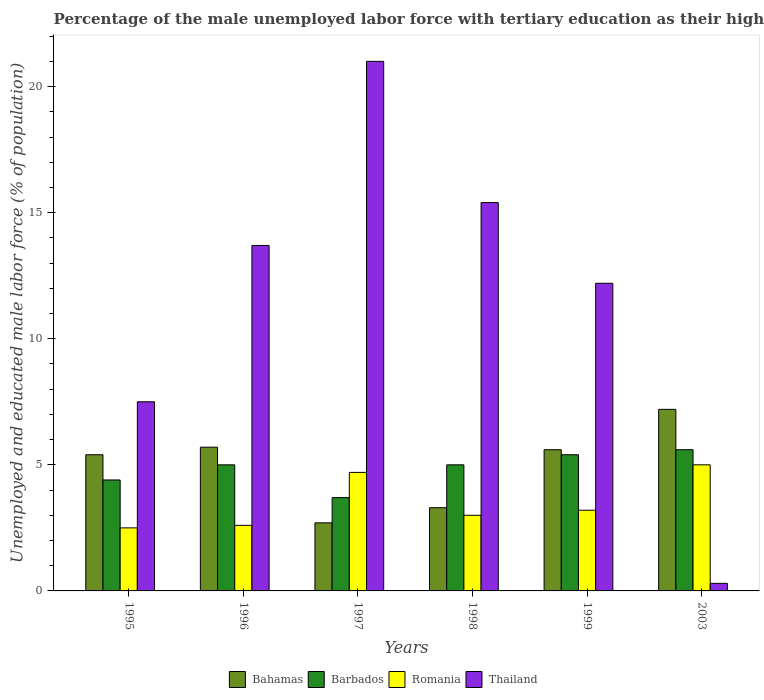How many bars are there on the 4th tick from the left?
Your answer should be very brief. 4. How many bars are there on the 4th tick from the right?
Offer a terse response. 4. In how many cases, is the number of bars for a given year not equal to the number of legend labels?
Offer a very short reply. 0. Across all years, what is the minimum percentage of the unemployed male labor force with tertiary education in Barbados?
Your answer should be very brief. 3.7. In which year was the percentage of the unemployed male labor force with tertiary education in Romania maximum?
Keep it short and to the point. 2003. What is the total percentage of the unemployed male labor force with tertiary education in Thailand in the graph?
Keep it short and to the point. 70.1. What is the difference between the percentage of the unemployed male labor force with tertiary education in Bahamas in 1999 and that in 2003?
Offer a very short reply. -1.6. What is the difference between the percentage of the unemployed male labor force with tertiary education in Barbados in 2003 and the percentage of the unemployed male labor force with tertiary education in Thailand in 1996?
Make the answer very short. -8.1. What is the average percentage of the unemployed male labor force with tertiary education in Thailand per year?
Your response must be concise. 11.68. In the year 1998, what is the difference between the percentage of the unemployed male labor force with tertiary education in Bahamas and percentage of the unemployed male labor force with tertiary education in Romania?
Ensure brevity in your answer.  0.3. In how many years, is the percentage of the unemployed male labor force with tertiary education in Romania greater than 1 %?
Offer a terse response. 6. What is the ratio of the percentage of the unemployed male labor force with tertiary education in Thailand in 1995 to that in 2003?
Your answer should be compact. 25. Is the percentage of the unemployed male labor force with tertiary education in Barbados in 1995 less than that in 1997?
Make the answer very short. No. Is the difference between the percentage of the unemployed male labor force with tertiary education in Bahamas in 1996 and 1998 greater than the difference between the percentage of the unemployed male labor force with tertiary education in Romania in 1996 and 1998?
Provide a short and direct response. Yes. What is the difference between the highest and the second highest percentage of the unemployed male labor force with tertiary education in Thailand?
Offer a terse response. 5.6. What is the difference between the highest and the lowest percentage of the unemployed male labor force with tertiary education in Romania?
Give a very brief answer. 2.5. What does the 3rd bar from the left in 1997 represents?
Give a very brief answer. Romania. What does the 2nd bar from the right in 2003 represents?
Offer a terse response. Romania. Is it the case that in every year, the sum of the percentage of the unemployed male labor force with tertiary education in Romania and percentage of the unemployed male labor force with tertiary education in Bahamas is greater than the percentage of the unemployed male labor force with tertiary education in Thailand?
Give a very brief answer. No. How many bars are there?
Make the answer very short. 24. Are all the bars in the graph horizontal?
Your answer should be compact. No. How many legend labels are there?
Offer a very short reply. 4. What is the title of the graph?
Your answer should be compact. Percentage of the male unemployed labor force with tertiary education as their highest grade. Does "Low income" appear as one of the legend labels in the graph?
Provide a succinct answer. No. What is the label or title of the Y-axis?
Keep it short and to the point. Unemployed and educated male labor force (% of population). What is the Unemployed and educated male labor force (% of population) in Bahamas in 1995?
Give a very brief answer. 5.4. What is the Unemployed and educated male labor force (% of population) in Barbados in 1995?
Keep it short and to the point. 4.4. What is the Unemployed and educated male labor force (% of population) of Romania in 1995?
Provide a short and direct response. 2.5. What is the Unemployed and educated male labor force (% of population) of Thailand in 1995?
Give a very brief answer. 7.5. What is the Unemployed and educated male labor force (% of population) in Bahamas in 1996?
Make the answer very short. 5.7. What is the Unemployed and educated male labor force (% of population) of Barbados in 1996?
Make the answer very short. 5. What is the Unemployed and educated male labor force (% of population) of Romania in 1996?
Offer a very short reply. 2.6. What is the Unemployed and educated male labor force (% of population) of Thailand in 1996?
Your response must be concise. 13.7. What is the Unemployed and educated male labor force (% of population) in Bahamas in 1997?
Keep it short and to the point. 2.7. What is the Unemployed and educated male labor force (% of population) in Barbados in 1997?
Ensure brevity in your answer.  3.7. What is the Unemployed and educated male labor force (% of population) in Romania in 1997?
Keep it short and to the point. 4.7. What is the Unemployed and educated male labor force (% of population) of Thailand in 1997?
Provide a short and direct response. 21. What is the Unemployed and educated male labor force (% of population) in Bahamas in 1998?
Your response must be concise. 3.3. What is the Unemployed and educated male labor force (% of population) in Thailand in 1998?
Offer a terse response. 15.4. What is the Unemployed and educated male labor force (% of population) of Bahamas in 1999?
Give a very brief answer. 5.6. What is the Unemployed and educated male labor force (% of population) of Barbados in 1999?
Your answer should be compact. 5.4. What is the Unemployed and educated male labor force (% of population) in Romania in 1999?
Give a very brief answer. 3.2. What is the Unemployed and educated male labor force (% of population) of Thailand in 1999?
Give a very brief answer. 12.2. What is the Unemployed and educated male labor force (% of population) in Bahamas in 2003?
Keep it short and to the point. 7.2. What is the Unemployed and educated male labor force (% of population) in Barbados in 2003?
Your answer should be very brief. 5.6. What is the Unemployed and educated male labor force (% of population) of Romania in 2003?
Your response must be concise. 5. What is the Unemployed and educated male labor force (% of population) of Thailand in 2003?
Keep it short and to the point. 0.3. Across all years, what is the maximum Unemployed and educated male labor force (% of population) of Bahamas?
Offer a very short reply. 7.2. Across all years, what is the maximum Unemployed and educated male labor force (% of population) of Barbados?
Your response must be concise. 5.6. Across all years, what is the maximum Unemployed and educated male labor force (% of population) in Thailand?
Ensure brevity in your answer.  21. Across all years, what is the minimum Unemployed and educated male labor force (% of population) in Bahamas?
Keep it short and to the point. 2.7. Across all years, what is the minimum Unemployed and educated male labor force (% of population) of Barbados?
Give a very brief answer. 3.7. Across all years, what is the minimum Unemployed and educated male labor force (% of population) in Thailand?
Your answer should be compact. 0.3. What is the total Unemployed and educated male labor force (% of population) of Bahamas in the graph?
Your response must be concise. 29.9. What is the total Unemployed and educated male labor force (% of population) in Barbados in the graph?
Give a very brief answer. 29.1. What is the total Unemployed and educated male labor force (% of population) in Romania in the graph?
Provide a succinct answer. 21. What is the total Unemployed and educated male labor force (% of population) of Thailand in the graph?
Your answer should be compact. 70.1. What is the difference between the Unemployed and educated male labor force (% of population) of Romania in 1995 and that in 1996?
Provide a succinct answer. -0.1. What is the difference between the Unemployed and educated male labor force (% of population) in Bahamas in 1995 and that in 1997?
Your answer should be very brief. 2.7. What is the difference between the Unemployed and educated male labor force (% of population) in Romania in 1995 and that in 1997?
Keep it short and to the point. -2.2. What is the difference between the Unemployed and educated male labor force (% of population) of Thailand in 1995 and that in 1997?
Provide a short and direct response. -13.5. What is the difference between the Unemployed and educated male labor force (% of population) in Bahamas in 1995 and that in 1998?
Your response must be concise. 2.1. What is the difference between the Unemployed and educated male labor force (% of population) of Romania in 1995 and that in 1998?
Make the answer very short. -0.5. What is the difference between the Unemployed and educated male labor force (% of population) of Thailand in 1995 and that in 1998?
Offer a very short reply. -7.9. What is the difference between the Unemployed and educated male labor force (% of population) of Bahamas in 1995 and that in 1999?
Your answer should be very brief. -0.2. What is the difference between the Unemployed and educated male labor force (% of population) of Barbados in 1995 and that in 1999?
Give a very brief answer. -1. What is the difference between the Unemployed and educated male labor force (% of population) of Romania in 1995 and that in 1999?
Your answer should be very brief. -0.7. What is the difference between the Unemployed and educated male labor force (% of population) in Thailand in 1995 and that in 1999?
Keep it short and to the point. -4.7. What is the difference between the Unemployed and educated male labor force (% of population) in Barbados in 1995 and that in 2003?
Provide a succinct answer. -1.2. What is the difference between the Unemployed and educated male labor force (% of population) in Thailand in 1995 and that in 2003?
Offer a very short reply. 7.2. What is the difference between the Unemployed and educated male labor force (% of population) of Bahamas in 1996 and that in 1997?
Provide a short and direct response. 3. What is the difference between the Unemployed and educated male labor force (% of population) in Romania in 1996 and that in 1997?
Offer a very short reply. -2.1. What is the difference between the Unemployed and educated male labor force (% of population) in Thailand in 1996 and that in 1997?
Offer a terse response. -7.3. What is the difference between the Unemployed and educated male labor force (% of population) in Barbados in 1996 and that in 1998?
Your response must be concise. 0. What is the difference between the Unemployed and educated male labor force (% of population) in Romania in 1996 and that in 1998?
Give a very brief answer. -0.4. What is the difference between the Unemployed and educated male labor force (% of population) of Bahamas in 1996 and that in 1999?
Give a very brief answer. 0.1. What is the difference between the Unemployed and educated male labor force (% of population) of Barbados in 1996 and that in 1999?
Your response must be concise. -0.4. What is the difference between the Unemployed and educated male labor force (% of population) in Thailand in 1996 and that in 1999?
Your answer should be compact. 1.5. What is the difference between the Unemployed and educated male labor force (% of population) of Bahamas in 1996 and that in 2003?
Ensure brevity in your answer.  -1.5. What is the difference between the Unemployed and educated male labor force (% of population) in Barbados in 1996 and that in 2003?
Provide a succinct answer. -0.6. What is the difference between the Unemployed and educated male labor force (% of population) of Thailand in 1996 and that in 2003?
Offer a terse response. 13.4. What is the difference between the Unemployed and educated male labor force (% of population) in Bahamas in 1997 and that in 1998?
Your response must be concise. -0.6. What is the difference between the Unemployed and educated male labor force (% of population) in Barbados in 1997 and that in 1998?
Your response must be concise. -1.3. What is the difference between the Unemployed and educated male labor force (% of population) of Thailand in 1997 and that in 1998?
Ensure brevity in your answer.  5.6. What is the difference between the Unemployed and educated male labor force (% of population) of Bahamas in 1997 and that in 1999?
Provide a short and direct response. -2.9. What is the difference between the Unemployed and educated male labor force (% of population) of Barbados in 1997 and that in 1999?
Ensure brevity in your answer.  -1.7. What is the difference between the Unemployed and educated male labor force (% of population) in Thailand in 1997 and that in 1999?
Your response must be concise. 8.8. What is the difference between the Unemployed and educated male labor force (% of population) of Bahamas in 1997 and that in 2003?
Your answer should be very brief. -4.5. What is the difference between the Unemployed and educated male labor force (% of population) in Barbados in 1997 and that in 2003?
Provide a succinct answer. -1.9. What is the difference between the Unemployed and educated male labor force (% of population) of Thailand in 1997 and that in 2003?
Your response must be concise. 20.7. What is the difference between the Unemployed and educated male labor force (% of population) of Bahamas in 1998 and that in 1999?
Keep it short and to the point. -2.3. What is the difference between the Unemployed and educated male labor force (% of population) in Barbados in 1998 and that in 1999?
Make the answer very short. -0.4. What is the difference between the Unemployed and educated male labor force (% of population) of Thailand in 1998 and that in 1999?
Your response must be concise. 3.2. What is the difference between the Unemployed and educated male labor force (% of population) of Bahamas in 1998 and that in 2003?
Make the answer very short. -3.9. What is the difference between the Unemployed and educated male labor force (% of population) of Barbados in 1998 and that in 2003?
Provide a short and direct response. -0.6. What is the difference between the Unemployed and educated male labor force (% of population) in Romania in 1998 and that in 2003?
Provide a succinct answer. -2. What is the difference between the Unemployed and educated male labor force (% of population) of Thailand in 1998 and that in 2003?
Ensure brevity in your answer.  15.1. What is the difference between the Unemployed and educated male labor force (% of population) in Bahamas in 1999 and that in 2003?
Ensure brevity in your answer.  -1.6. What is the difference between the Unemployed and educated male labor force (% of population) in Bahamas in 1995 and the Unemployed and educated male labor force (% of population) in Barbados in 1996?
Offer a very short reply. 0.4. What is the difference between the Unemployed and educated male labor force (% of population) in Bahamas in 1995 and the Unemployed and educated male labor force (% of population) in Romania in 1996?
Keep it short and to the point. 2.8. What is the difference between the Unemployed and educated male labor force (% of population) in Barbados in 1995 and the Unemployed and educated male labor force (% of population) in Thailand in 1996?
Provide a succinct answer. -9.3. What is the difference between the Unemployed and educated male labor force (% of population) in Romania in 1995 and the Unemployed and educated male labor force (% of population) in Thailand in 1996?
Your answer should be very brief. -11.2. What is the difference between the Unemployed and educated male labor force (% of population) in Bahamas in 1995 and the Unemployed and educated male labor force (% of population) in Romania in 1997?
Your response must be concise. 0.7. What is the difference between the Unemployed and educated male labor force (% of population) of Bahamas in 1995 and the Unemployed and educated male labor force (% of population) of Thailand in 1997?
Keep it short and to the point. -15.6. What is the difference between the Unemployed and educated male labor force (% of population) of Barbados in 1995 and the Unemployed and educated male labor force (% of population) of Romania in 1997?
Offer a very short reply. -0.3. What is the difference between the Unemployed and educated male labor force (% of population) in Barbados in 1995 and the Unemployed and educated male labor force (% of population) in Thailand in 1997?
Your answer should be compact. -16.6. What is the difference between the Unemployed and educated male labor force (% of population) of Romania in 1995 and the Unemployed and educated male labor force (% of population) of Thailand in 1997?
Provide a succinct answer. -18.5. What is the difference between the Unemployed and educated male labor force (% of population) of Bahamas in 1995 and the Unemployed and educated male labor force (% of population) of Romania in 1998?
Offer a very short reply. 2.4. What is the difference between the Unemployed and educated male labor force (% of population) of Bahamas in 1995 and the Unemployed and educated male labor force (% of population) of Thailand in 1998?
Provide a succinct answer. -10. What is the difference between the Unemployed and educated male labor force (% of population) of Barbados in 1995 and the Unemployed and educated male labor force (% of population) of Romania in 1998?
Your answer should be compact. 1.4. What is the difference between the Unemployed and educated male labor force (% of population) in Barbados in 1995 and the Unemployed and educated male labor force (% of population) in Thailand in 1998?
Keep it short and to the point. -11. What is the difference between the Unemployed and educated male labor force (% of population) in Bahamas in 1995 and the Unemployed and educated male labor force (% of population) in Barbados in 1999?
Provide a short and direct response. 0. What is the difference between the Unemployed and educated male labor force (% of population) of Bahamas in 1995 and the Unemployed and educated male labor force (% of population) of Romania in 1999?
Your response must be concise. 2.2. What is the difference between the Unemployed and educated male labor force (% of population) of Bahamas in 1995 and the Unemployed and educated male labor force (% of population) of Thailand in 1999?
Provide a succinct answer. -6.8. What is the difference between the Unemployed and educated male labor force (% of population) of Barbados in 1995 and the Unemployed and educated male labor force (% of population) of Romania in 1999?
Your response must be concise. 1.2. What is the difference between the Unemployed and educated male labor force (% of population) of Barbados in 1995 and the Unemployed and educated male labor force (% of population) of Thailand in 1999?
Your answer should be compact. -7.8. What is the difference between the Unemployed and educated male labor force (% of population) of Barbados in 1995 and the Unemployed and educated male labor force (% of population) of Thailand in 2003?
Give a very brief answer. 4.1. What is the difference between the Unemployed and educated male labor force (% of population) of Bahamas in 1996 and the Unemployed and educated male labor force (% of population) of Barbados in 1997?
Give a very brief answer. 2. What is the difference between the Unemployed and educated male labor force (% of population) of Bahamas in 1996 and the Unemployed and educated male labor force (% of population) of Thailand in 1997?
Your response must be concise. -15.3. What is the difference between the Unemployed and educated male labor force (% of population) of Barbados in 1996 and the Unemployed and educated male labor force (% of population) of Thailand in 1997?
Make the answer very short. -16. What is the difference between the Unemployed and educated male labor force (% of population) in Romania in 1996 and the Unemployed and educated male labor force (% of population) in Thailand in 1997?
Provide a short and direct response. -18.4. What is the difference between the Unemployed and educated male labor force (% of population) of Bahamas in 1996 and the Unemployed and educated male labor force (% of population) of Barbados in 1998?
Provide a succinct answer. 0.7. What is the difference between the Unemployed and educated male labor force (% of population) in Bahamas in 1996 and the Unemployed and educated male labor force (% of population) in Thailand in 1998?
Make the answer very short. -9.7. What is the difference between the Unemployed and educated male labor force (% of population) of Barbados in 1996 and the Unemployed and educated male labor force (% of population) of Thailand in 1998?
Make the answer very short. -10.4. What is the difference between the Unemployed and educated male labor force (% of population) in Romania in 1996 and the Unemployed and educated male labor force (% of population) in Thailand in 1998?
Ensure brevity in your answer.  -12.8. What is the difference between the Unemployed and educated male labor force (% of population) of Bahamas in 1996 and the Unemployed and educated male labor force (% of population) of Thailand in 1999?
Your response must be concise. -6.5. What is the difference between the Unemployed and educated male labor force (% of population) of Barbados in 1996 and the Unemployed and educated male labor force (% of population) of Romania in 1999?
Give a very brief answer. 1.8. What is the difference between the Unemployed and educated male labor force (% of population) of Barbados in 1996 and the Unemployed and educated male labor force (% of population) of Thailand in 1999?
Your answer should be compact. -7.2. What is the difference between the Unemployed and educated male labor force (% of population) of Bahamas in 1996 and the Unemployed and educated male labor force (% of population) of Barbados in 2003?
Your response must be concise. 0.1. What is the difference between the Unemployed and educated male labor force (% of population) of Bahamas in 1996 and the Unemployed and educated male labor force (% of population) of Thailand in 2003?
Offer a very short reply. 5.4. What is the difference between the Unemployed and educated male labor force (% of population) in Barbados in 1996 and the Unemployed and educated male labor force (% of population) in Romania in 2003?
Provide a succinct answer. 0. What is the difference between the Unemployed and educated male labor force (% of population) of Bahamas in 1997 and the Unemployed and educated male labor force (% of population) of Romania in 1998?
Offer a very short reply. -0.3. What is the difference between the Unemployed and educated male labor force (% of population) of Barbados in 1997 and the Unemployed and educated male labor force (% of population) of Romania in 1998?
Your answer should be very brief. 0.7. What is the difference between the Unemployed and educated male labor force (% of population) in Romania in 1997 and the Unemployed and educated male labor force (% of population) in Thailand in 1998?
Offer a terse response. -10.7. What is the difference between the Unemployed and educated male labor force (% of population) of Bahamas in 1997 and the Unemployed and educated male labor force (% of population) of Barbados in 1999?
Provide a succinct answer. -2.7. What is the difference between the Unemployed and educated male labor force (% of population) of Bahamas in 1997 and the Unemployed and educated male labor force (% of population) of Thailand in 1999?
Give a very brief answer. -9.5. What is the difference between the Unemployed and educated male labor force (% of population) in Barbados in 1997 and the Unemployed and educated male labor force (% of population) in Romania in 1999?
Offer a terse response. 0.5. What is the difference between the Unemployed and educated male labor force (% of population) in Bahamas in 1997 and the Unemployed and educated male labor force (% of population) in Barbados in 2003?
Your response must be concise. -2.9. What is the difference between the Unemployed and educated male labor force (% of population) of Bahamas in 1997 and the Unemployed and educated male labor force (% of population) of Romania in 2003?
Make the answer very short. -2.3. What is the difference between the Unemployed and educated male labor force (% of population) in Bahamas in 1997 and the Unemployed and educated male labor force (% of population) in Thailand in 2003?
Make the answer very short. 2.4. What is the difference between the Unemployed and educated male labor force (% of population) in Barbados in 1997 and the Unemployed and educated male labor force (% of population) in Romania in 2003?
Your response must be concise. -1.3. What is the difference between the Unemployed and educated male labor force (% of population) of Romania in 1997 and the Unemployed and educated male labor force (% of population) of Thailand in 2003?
Ensure brevity in your answer.  4.4. What is the difference between the Unemployed and educated male labor force (% of population) in Bahamas in 1998 and the Unemployed and educated male labor force (% of population) in Romania in 1999?
Give a very brief answer. 0.1. What is the difference between the Unemployed and educated male labor force (% of population) of Bahamas in 1998 and the Unemployed and educated male labor force (% of population) of Thailand in 1999?
Ensure brevity in your answer.  -8.9. What is the difference between the Unemployed and educated male labor force (% of population) of Romania in 1998 and the Unemployed and educated male labor force (% of population) of Thailand in 1999?
Provide a short and direct response. -9.2. What is the difference between the Unemployed and educated male labor force (% of population) in Bahamas in 1998 and the Unemployed and educated male labor force (% of population) in Barbados in 2003?
Offer a terse response. -2.3. What is the difference between the Unemployed and educated male labor force (% of population) of Bahamas in 1998 and the Unemployed and educated male labor force (% of population) of Romania in 2003?
Offer a terse response. -1.7. What is the difference between the Unemployed and educated male labor force (% of population) of Barbados in 1998 and the Unemployed and educated male labor force (% of population) of Romania in 2003?
Offer a terse response. 0. What is the difference between the Unemployed and educated male labor force (% of population) in Barbados in 1998 and the Unemployed and educated male labor force (% of population) in Thailand in 2003?
Offer a terse response. 4.7. What is the difference between the Unemployed and educated male labor force (% of population) in Bahamas in 1999 and the Unemployed and educated male labor force (% of population) in Barbados in 2003?
Your answer should be very brief. 0. What is the difference between the Unemployed and educated male labor force (% of population) of Bahamas in 1999 and the Unemployed and educated male labor force (% of population) of Thailand in 2003?
Ensure brevity in your answer.  5.3. What is the difference between the Unemployed and educated male labor force (% of population) of Barbados in 1999 and the Unemployed and educated male labor force (% of population) of Thailand in 2003?
Give a very brief answer. 5.1. What is the average Unemployed and educated male labor force (% of population) of Bahamas per year?
Keep it short and to the point. 4.98. What is the average Unemployed and educated male labor force (% of population) of Barbados per year?
Your answer should be very brief. 4.85. What is the average Unemployed and educated male labor force (% of population) in Romania per year?
Your answer should be compact. 3.5. What is the average Unemployed and educated male labor force (% of population) in Thailand per year?
Your answer should be very brief. 11.68. In the year 1995, what is the difference between the Unemployed and educated male labor force (% of population) in Bahamas and Unemployed and educated male labor force (% of population) in Romania?
Provide a short and direct response. 2.9. In the year 1996, what is the difference between the Unemployed and educated male labor force (% of population) in Bahamas and Unemployed and educated male labor force (% of population) in Barbados?
Provide a short and direct response. 0.7. In the year 1996, what is the difference between the Unemployed and educated male labor force (% of population) of Bahamas and Unemployed and educated male labor force (% of population) of Romania?
Offer a terse response. 3.1. In the year 1996, what is the difference between the Unemployed and educated male labor force (% of population) in Bahamas and Unemployed and educated male labor force (% of population) in Thailand?
Your answer should be very brief. -8. In the year 1997, what is the difference between the Unemployed and educated male labor force (% of population) in Bahamas and Unemployed and educated male labor force (% of population) in Barbados?
Ensure brevity in your answer.  -1. In the year 1997, what is the difference between the Unemployed and educated male labor force (% of population) of Bahamas and Unemployed and educated male labor force (% of population) of Thailand?
Your response must be concise. -18.3. In the year 1997, what is the difference between the Unemployed and educated male labor force (% of population) of Barbados and Unemployed and educated male labor force (% of population) of Thailand?
Your answer should be compact. -17.3. In the year 1997, what is the difference between the Unemployed and educated male labor force (% of population) of Romania and Unemployed and educated male labor force (% of population) of Thailand?
Make the answer very short. -16.3. In the year 1998, what is the difference between the Unemployed and educated male labor force (% of population) of Bahamas and Unemployed and educated male labor force (% of population) of Romania?
Your answer should be compact. 0.3. In the year 1998, what is the difference between the Unemployed and educated male labor force (% of population) of Bahamas and Unemployed and educated male labor force (% of population) of Thailand?
Give a very brief answer. -12.1. In the year 1998, what is the difference between the Unemployed and educated male labor force (% of population) in Barbados and Unemployed and educated male labor force (% of population) in Romania?
Make the answer very short. 2. In the year 1998, what is the difference between the Unemployed and educated male labor force (% of population) in Barbados and Unemployed and educated male labor force (% of population) in Thailand?
Ensure brevity in your answer.  -10.4. In the year 1998, what is the difference between the Unemployed and educated male labor force (% of population) in Romania and Unemployed and educated male labor force (% of population) in Thailand?
Offer a very short reply. -12.4. In the year 1999, what is the difference between the Unemployed and educated male labor force (% of population) of Romania and Unemployed and educated male labor force (% of population) of Thailand?
Your response must be concise. -9. In the year 2003, what is the difference between the Unemployed and educated male labor force (% of population) of Bahamas and Unemployed and educated male labor force (% of population) of Thailand?
Your answer should be compact. 6.9. In the year 2003, what is the difference between the Unemployed and educated male labor force (% of population) of Barbados and Unemployed and educated male labor force (% of population) of Romania?
Your answer should be compact. 0.6. In the year 2003, what is the difference between the Unemployed and educated male labor force (% of population) in Barbados and Unemployed and educated male labor force (% of population) in Thailand?
Make the answer very short. 5.3. In the year 2003, what is the difference between the Unemployed and educated male labor force (% of population) in Romania and Unemployed and educated male labor force (% of population) in Thailand?
Offer a very short reply. 4.7. What is the ratio of the Unemployed and educated male labor force (% of population) in Romania in 1995 to that in 1996?
Ensure brevity in your answer.  0.96. What is the ratio of the Unemployed and educated male labor force (% of population) of Thailand in 1995 to that in 1996?
Provide a succinct answer. 0.55. What is the ratio of the Unemployed and educated male labor force (% of population) of Bahamas in 1995 to that in 1997?
Make the answer very short. 2. What is the ratio of the Unemployed and educated male labor force (% of population) in Barbados in 1995 to that in 1997?
Your response must be concise. 1.19. What is the ratio of the Unemployed and educated male labor force (% of population) of Romania in 1995 to that in 1997?
Keep it short and to the point. 0.53. What is the ratio of the Unemployed and educated male labor force (% of population) in Thailand in 1995 to that in 1997?
Give a very brief answer. 0.36. What is the ratio of the Unemployed and educated male labor force (% of population) of Bahamas in 1995 to that in 1998?
Offer a very short reply. 1.64. What is the ratio of the Unemployed and educated male labor force (% of population) in Romania in 1995 to that in 1998?
Ensure brevity in your answer.  0.83. What is the ratio of the Unemployed and educated male labor force (% of population) in Thailand in 1995 to that in 1998?
Your answer should be compact. 0.49. What is the ratio of the Unemployed and educated male labor force (% of population) in Bahamas in 1995 to that in 1999?
Ensure brevity in your answer.  0.96. What is the ratio of the Unemployed and educated male labor force (% of population) in Barbados in 1995 to that in 1999?
Keep it short and to the point. 0.81. What is the ratio of the Unemployed and educated male labor force (% of population) of Romania in 1995 to that in 1999?
Your response must be concise. 0.78. What is the ratio of the Unemployed and educated male labor force (% of population) in Thailand in 1995 to that in 1999?
Offer a very short reply. 0.61. What is the ratio of the Unemployed and educated male labor force (% of population) in Barbados in 1995 to that in 2003?
Keep it short and to the point. 0.79. What is the ratio of the Unemployed and educated male labor force (% of population) in Romania in 1995 to that in 2003?
Your answer should be very brief. 0.5. What is the ratio of the Unemployed and educated male labor force (% of population) in Bahamas in 1996 to that in 1997?
Keep it short and to the point. 2.11. What is the ratio of the Unemployed and educated male labor force (% of population) of Barbados in 1996 to that in 1997?
Offer a terse response. 1.35. What is the ratio of the Unemployed and educated male labor force (% of population) of Romania in 1996 to that in 1997?
Offer a very short reply. 0.55. What is the ratio of the Unemployed and educated male labor force (% of population) in Thailand in 1996 to that in 1997?
Offer a terse response. 0.65. What is the ratio of the Unemployed and educated male labor force (% of population) of Bahamas in 1996 to that in 1998?
Your response must be concise. 1.73. What is the ratio of the Unemployed and educated male labor force (% of population) in Romania in 1996 to that in 1998?
Your answer should be very brief. 0.87. What is the ratio of the Unemployed and educated male labor force (% of population) in Thailand in 1996 to that in 1998?
Make the answer very short. 0.89. What is the ratio of the Unemployed and educated male labor force (% of population) in Bahamas in 1996 to that in 1999?
Provide a short and direct response. 1.02. What is the ratio of the Unemployed and educated male labor force (% of population) of Barbados in 1996 to that in 1999?
Offer a very short reply. 0.93. What is the ratio of the Unemployed and educated male labor force (% of population) in Romania in 1996 to that in 1999?
Your answer should be very brief. 0.81. What is the ratio of the Unemployed and educated male labor force (% of population) of Thailand in 1996 to that in 1999?
Offer a terse response. 1.12. What is the ratio of the Unemployed and educated male labor force (% of population) of Bahamas in 1996 to that in 2003?
Give a very brief answer. 0.79. What is the ratio of the Unemployed and educated male labor force (% of population) in Barbados in 1996 to that in 2003?
Offer a terse response. 0.89. What is the ratio of the Unemployed and educated male labor force (% of population) in Romania in 1996 to that in 2003?
Your answer should be very brief. 0.52. What is the ratio of the Unemployed and educated male labor force (% of population) in Thailand in 1996 to that in 2003?
Offer a very short reply. 45.67. What is the ratio of the Unemployed and educated male labor force (% of population) in Bahamas in 1997 to that in 1998?
Give a very brief answer. 0.82. What is the ratio of the Unemployed and educated male labor force (% of population) of Barbados in 1997 to that in 1998?
Offer a terse response. 0.74. What is the ratio of the Unemployed and educated male labor force (% of population) in Romania in 1997 to that in 1998?
Give a very brief answer. 1.57. What is the ratio of the Unemployed and educated male labor force (% of population) in Thailand in 1997 to that in 1998?
Your response must be concise. 1.36. What is the ratio of the Unemployed and educated male labor force (% of population) of Bahamas in 1997 to that in 1999?
Keep it short and to the point. 0.48. What is the ratio of the Unemployed and educated male labor force (% of population) in Barbados in 1997 to that in 1999?
Your response must be concise. 0.69. What is the ratio of the Unemployed and educated male labor force (% of population) of Romania in 1997 to that in 1999?
Give a very brief answer. 1.47. What is the ratio of the Unemployed and educated male labor force (% of population) in Thailand in 1997 to that in 1999?
Provide a succinct answer. 1.72. What is the ratio of the Unemployed and educated male labor force (% of population) in Bahamas in 1997 to that in 2003?
Your answer should be compact. 0.38. What is the ratio of the Unemployed and educated male labor force (% of population) of Barbados in 1997 to that in 2003?
Make the answer very short. 0.66. What is the ratio of the Unemployed and educated male labor force (% of population) of Thailand in 1997 to that in 2003?
Offer a terse response. 70. What is the ratio of the Unemployed and educated male labor force (% of population) of Bahamas in 1998 to that in 1999?
Ensure brevity in your answer.  0.59. What is the ratio of the Unemployed and educated male labor force (% of population) of Barbados in 1998 to that in 1999?
Make the answer very short. 0.93. What is the ratio of the Unemployed and educated male labor force (% of population) in Romania in 1998 to that in 1999?
Your response must be concise. 0.94. What is the ratio of the Unemployed and educated male labor force (% of population) in Thailand in 1998 to that in 1999?
Your answer should be compact. 1.26. What is the ratio of the Unemployed and educated male labor force (% of population) in Bahamas in 1998 to that in 2003?
Your response must be concise. 0.46. What is the ratio of the Unemployed and educated male labor force (% of population) in Barbados in 1998 to that in 2003?
Your answer should be compact. 0.89. What is the ratio of the Unemployed and educated male labor force (% of population) in Romania in 1998 to that in 2003?
Provide a succinct answer. 0.6. What is the ratio of the Unemployed and educated male labor force (% of population) of Thailand in 1998 to that in 2003?
Your answer should be very brief. 51.33. What is the ratio of the Unemployed and educated male labor force (% of population) of Barbados in 1999 to that in 2003?
Offer a very short reply. 0.96. What is the ratio of the Unemployed and educated male labor force (% of population) of Romania in 1999 to that in 2003?
Make the answer very short. 0.64. What is the ratio of the Unemployed and educated male labor force (% of population) in Thailand in 1999 to that in 2003?
Offer a very short reply. 40.67. What is the difference between the highest and the second highest Unemployed and educated male labor force (% of population) of Bahamas?
Keep it short and to the point. 1.5. What is the difference between the highest and the second highest Unemployed and educated male labor force (% of population) of Romania?
Offer a very short reply. 0.3. What is the difference between the highest and the lowest Unemployed and educated male labor force (% of population) of Barbados?
Make the answer very short. 1.9. What is the difference between the highest and the lowest Unemployed and educated male labor force (% of population) in Romania?
Keep it short and to the point. 2.5. What is the difference between the highest and the lowest Unemployed and educated male labor force (% of population) of Thailand?
Give a very brief answer. 20.7. 